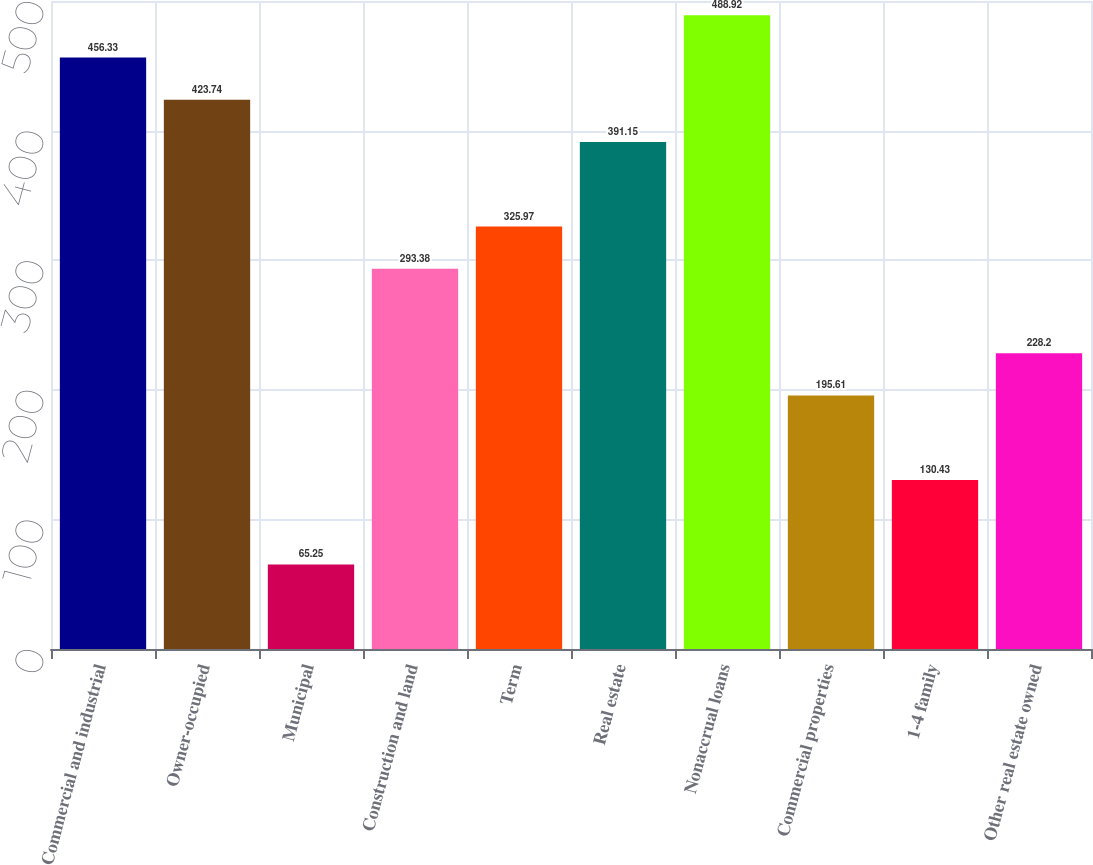Convert chart to OTSL. <chart><loc_0><loc_0><loc_500><loc_500><bar_chart><fcel>Commercial and industrial<fcel>Owner-occupied<fcel>Municipal<fcel>Construction and land<fcel>Term<fcel>Real estate<fcel>Nonaccrual loans<fcel>Commercial properties<fcel>1-4 family<fcel>Other real estate owned<nl><fcel>456.33<fcel>423.74<fcel>65.25<fcel>293.38<fcel>325.97<fcel>391.15<fcel>488.92<fcel>195.61<fcel>130.43<fcel>228.2<nl></chart> 